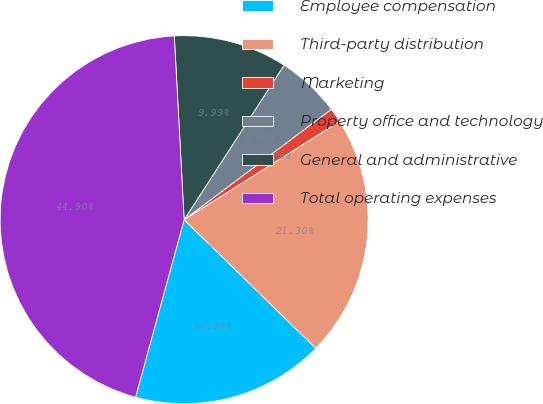<chart> <loc_0><loc_0><loc_500><loc_500><pie_chart><fcel>Employee compensation<fcel>Third-party distribution<fcel>Marketing<fcel>Property office and technology<fcel>General and administrative<fcel>Total operating expenses<nl><fcel>16.94%<fcel>21.3%<fcel>1.26%<fcel>5.62%<fcel>9.99%<fcel>44.9%<nl></chart> 